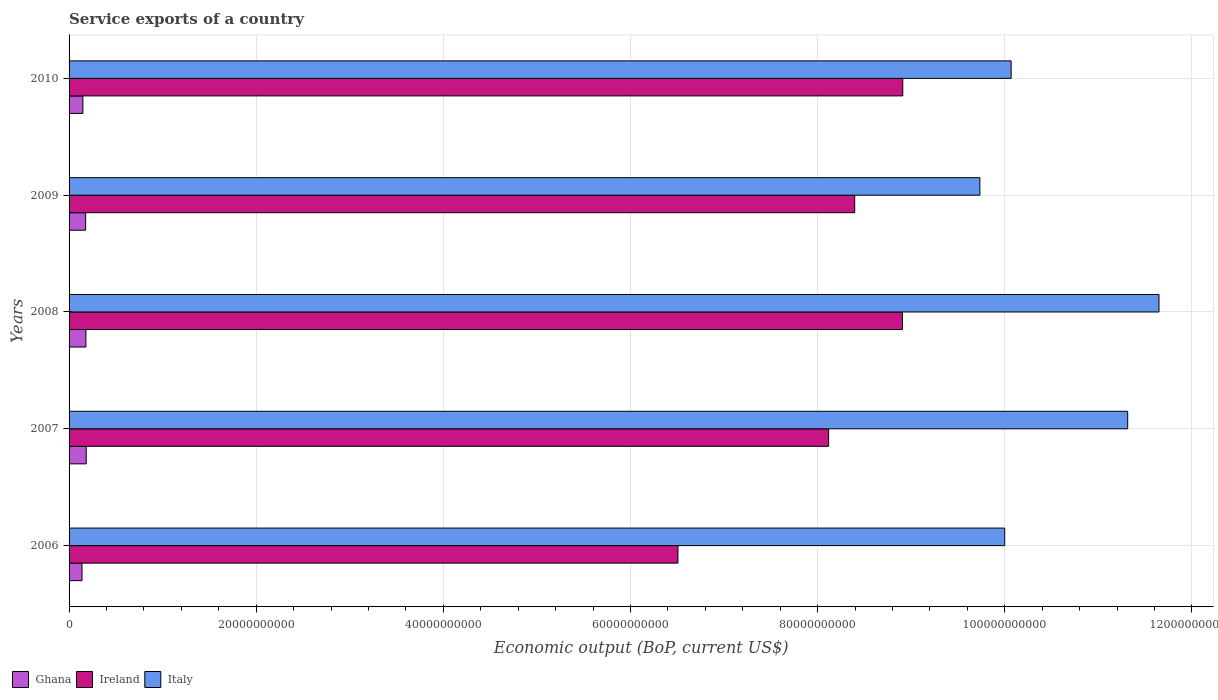How many different coloured bars are there?
Your answer should be compact. 3. How many groups of bars are there?
Your answer should be very brief. 5. Are the number of bars per tick equal to the number of legend labels?
Ensure brevity in your answer.  Yes. Are the number of bars on each tick of the Y-axis equal?
Make the answer very short. Yes. How many bars are there on the 4th tick from the top?
Your response must be concise. 3. How many bars are there on the 1st tick from the bottom?
Provide a short and direct response. 3. What is the label of the 5th group of bars from the top?
Keep it short and to the point. 2006. In how many cases, is the number of bars for a given year not equal to the number of legend labels?
Provide a short and direct response. 0. What is the service exports in Ireland in 2009?
Offer a very short reply. 8.40e+1. Across all years, what is the maximum service exports in Ghana?
Give a very brief answer. 1.83e+09. Across all years, what is the minimum service exports in Ireland?
Offer a terse response. 6.51e+1. In which year was the service exports in Ireland maximum?
Offer a very short reply. 2010. What is the total service exports in Ireland in the graph?
Provide a short and direct response. 4.08e+11. What is the difference between the service exports in Italy in 2006 and that in 2009?
Make the answer very short. 2.65e+09. What is the difference between the service exports in Italy in 2009 and the service exports in Ireland in 2007?
Offer a very short reply. 1.62e+1. What is the average service exports in Italy per year?
Offer a terse response. 1.06e+11. In the year 2010, what is the difference between the service exports in Ghana and service exports in Ireland?
Provide a succinct answer. -8.76e+1. In how many years, is the service exports in Italy greater than 68000000000 US$?
Provide a succinct answer. 5. What is the ratio of the service exports in Ireland in 2008 to that in 2009?
Give a very brief answer. 1.06. What is the difference between the highest and the second highest service exports in Italy?
Ensure brevity in your answer.  3.34e+09. What is the difference between the highest and the lowest service exports in Ghana?
Keep it short and to the point. 4.49e+08. In how many years, is the service exports in Italy greater than the average service exports in Italy taken over all years?
Provide a succinct answer. 2. Is the sum of the service exports in Ireland in 2006 and 2008 greater than the maximum service exports in Ghana across all years?
Make the answer very short. Yes. How many bars are there?
Offer a very short reply. 15. Are all the bars in the graph horizontal?
Provide a short and direct response. Yes. How many years are there in the graph?
Ensure brevity in your answer.  5. What is the difference between two consecutive major ticks on the X-axis?
Offer a terse response. 2.00e+1. Where does the legend appear in the graph?
Make the answer very short. Bottom left. How many legend labels are there?
Your answer should be very brief. 3. What is the title of the graph?
Provide a succinct answer. Service exports of a country. What is the label or title of the X-axis?
Your answer should be very brief. Economic output (BoP, current US$). What is the label or title of the Y-axis?
Provide a succinct answer. Years. What is the Economic output (BoP, current US$) of Ghana in 2006?
Your answer should be very brief. 1.38e+09. What is the Economic output (BoP, current US$) in Ireland in 2006?
Your response must be concise. 6.51e+1. What is the Economic output (BoP, current US$) of Italy in 2006?
Provide a short and direct response. 1.00e+11. What is the Economic output (BoP, current US$) in Ghana in 2007?
Offer a very short reply. 1.83e+09. What is the Economic output (BoP, current US$) of Ireland in 2007?
Provide a short and direct response. 8.12e+1. What is the Economic output (BoP, current US$) in Italy in 2007?
Offer a terse response. 1.13e+11. What is the Economic output (BoP, current US$) of Ghana in 2008?
Provide a short and direct response. 1.80e+09. What is the Economic output (BoP, current US$) in Ireland in 2008?
Provide a short and direct response. 8.91e+1. What is the Economic output (BoP, current US$) in Italy in 2008?
Provide a short and direct response. 1.16e+11. What is the Economic output (BoP, current US$) of Ghana in 2009?
Make the answer very short. 1.77e+09. What is the Economic output (BoP, current US$) in Ireland in 2009?
Offer a very short reply. 8.40e+1. What is the Economic output (BoP, current US$) of Italy in 2009?
Ensure brevity in your answer.  9.73e+1. What is the Economic output (BoP, current US$) in Ghana in 2010?
Keep it short and to the point. 1.48e+09. What is the Economic output (BoP, current US$) in Ireland in 2010?
Offer a very short reply. 8.91e+1. What is the Economic output (BoP, current US$) of Italy in 2010?
Your answer should be very brief. 1.01e+11. Across all years, what is the maximum Economic output (BoP, current US$) of Ghana?
Ensure brevity in your answer.  1.83e+09. Across all years, what is the maximum Economic output (BoP, current US$) in Ireland?
Your answer should be very brief. 8.91e+1. Across all years, what is the maximum Economic output (BoP, current US$) of Italy?
Give a very brief answer. 1.16e+11. Across all years, what is the minimum Economic output (BoP, current US$) in Ghana?
Your answer should be very brief. 1.38e+09. Across all years, what is the minimum Economic output (BoP, current US$) of Ireland?
Your answer should be compact. 6.51e+1. Across all years, what is the minimum Economic output (BoP, current US$) in Italy?
Your response must be concise. 9.73e+1. What is the total Economic output (BoP, current US$) in Ghana in the graph?
Offer a very short reply. 8.26e+09. What is the total Economic output (BoP, current US$) of Ireland in the graph?
Give a very brief answer. 4.08e+11. What is the total Economic output (BoP, current US$) in Italy in the graph?
Give a very brief answer. 5.28e+11. What is the difference between the Economic output (BoP, current US$) of Ghana in 2006 and that in 2007?
Your response must be concise. -4.49e+08. What is the difference between the Economic output (BoP, current US$) of Ireland in 2006 and that in 2007?
Your response must be concise. -1.61e+1. What is the difference between the Economic output (BoP, current US$) of Italy in 2006 and that in 2007?
Your answer should be very brief. -1.31e+1. What is the difference between the Economic output (BoP, current US$) in Ghana in 2006 and that in 2008?
Give a very brief answer. -4.18e+08. What is the difference between the Economic output (BoP, current US$) of Ireland in 2006 and that in 2008?
Give a very brief answer. -2.40e+1. What is the difference between the Economic output (BoP, current US$) of Italy in 2006 and that in 2008?
Ensure brevity in your answer.  -1.65e+1. What is the difference between the Economic output (BoP, current US$) of Ghana in 2006 and that in 2009?
Provide a succinct answer. -3.87e+08. What is the difference between the Economic output (BoP, current US$) in Ireland in 2006 and that in 2009?
Offer a very short reply. -1.89e+1. What is the difference between the Economic output (BoP, current US$) of Italy in 2006 and that in 2009?
Give a very brief answer. 2.65e+09. What is the difference between the Economic output (BoP, current US$) in Ghana in 2006 and that in 2010?
Your answer should be very brief. -9.45e+07. What is the difference between the Economic output (BoP, current US$) in Ireland in 2006 and that in 2010?
Give a very brief answer. -2.40e+1. What is the difference between the Economic output (BoP, current US$) of Italy in 2006 and that in 2010?
Offer a very short reply. -6.87e+08. What is the difference between the Economic output (BoP, current US$) of Ghana in 2007 and that in 2008?
Make the answer very short. 3.10e+07. What is the difference between the Economic output (BoP, current US$) of Ireland in 2007 and that in 2008?
Keep it short and to the point. -7.89e+09. What is the difference between the Economic output (BoP, current US$) of Italy in 2007 and that in 2008?
Your answer should be very brief. -3.34e+09. What is the difference between the Economic output (BoP, current US$) in Ghana in 2007 and that in 2009?
Provide a short and direct response. 6.22e+07. What is the difference between the Economic output (BoP, current US$) in Ireland in 2007 and that in 2009?
Offer a terse response. -2.79e+09. What is the difference between the Economic output (BoP, current US$) in Italy in 2007 and that in 2009?
Make the answer very short. 1.58e+1. What is the difference between the Economic output (BoP, current US$) of Ghana in 2007 and that in 2010?
Provide a short and direct response. 3.55e+08. What is the difference between the Economic output (BoP, current US$) in Ireland in 2007 and that in 2010?
Offer a terse response. -7.92e+09. What is the difference between the Economic output (BoP, current US$) of Italy in 2007 and that in 2010?
Ensure brevity in your answer.  1.25e+1. What is the difference between the Economic output (BoP, current US$) of Ghana in 2008 and that in 2009?
Your response must be concise. 3.12e+07. What is the difference between the Economic output (BoP, current US$) in Ireland in 2008 and that in 2009?
Offer a very short reply. 5.10e+09. What is the difference between the Economic output (BoP, current US$) of Italy in 2008 and that in 2009?
Make the answer very short. 1.91e+1. What is the difference between the Economic output (BoP, current US$) of Ghana in 2008 and that in 2010?
Make the answer very short. 3.24e+08. What is the difference between the Economic output (BoP, current US$) of Ireland in 2008 and that in 2010?
Make the answer very short. -3.44e+07. What is the difference between the Economic output (BoP, current US$) in Italy in 2008 and that in 2010?
Make the answer very short. 1.58e+1. What is the difference between the Economic output (BoP, current US$) of Ghana in 2009 and that in 2010?
Make the answer very short. 2.92e+08. What is the difference between the Economic output (BoP, current US$) in Ireland in 2009 and that in 2010?
Ensure brevity in your answer.  -5.14e+09. What is the difference between the Economic output (BoP, current US$) in Italy in 2009 and that in 2010?
Give a very brief answer. -3.34e+09. What is the difference between the Economic output (BoP, current US$) in Ghana in 2006 and the Economic output (BoP, current US$) in Ireland in 2007?
Your answer should be compact. -7.98e+1. What is the difference between the Economic output (BoP, current US$) of Ghana in 2006 and the Economic output (BoP, current US$) of Italy in 2007?
Make the answer very short. -1.12e+11. What is the difference between the Economic output (BoP, current US$) in Ireland in 2006 and the Economic output (BoP, current US$) in Italy in 2007?
Keep it short and to the point. -4.81e+1. What is the difference between the Economic output (BoP, current US$) in Ghana in 2006 and the Economic output (BoP, current US$) in Ireland in 2008?
Provide a short and direct response. -8.77e+1. What is the difference between the Economic output (BoP, current US$) in Ghana in 2006 and the Economic output (BoP, current US$) in Italy in 2008?
Offer a very short reply. -1.15e+11. What is the difference between the Economic output (BoP, current US$) in Ireland in 2006 and the Economic output (BoP, current US$) in Italy in 2008?
Keep it short and to the point. -5.14e+1. What is the difference between the Economic output (BoP, current US$) in Ghana in 2006 and the Economic output (BoP, current US$) in Ireland in 2009?
Give a very brief answer. -8.26e+1. What is the difference between the Economic output (BoP, current US$) of Ghana in 2006 and the Economic output (BoP, current US$) of Italy in 2009?
Ensure brevity in your answer.  -9.60e+1. What is the difference between the Economic output (BoP, current US$) in Ireland in 2006 and the Economic output (BoP, current US$) in Italy in 2009?
Provide a succinct answer. -3.23e+1. What is the difference between the Economic output (BoP, current US$) in Ghana in 2006 and the Economic output (BoP, current US$) in Ireland in 2010?
Give a very brief answer. -8.77e+1. What is the difference between the Economic output (BoP, current US$) in Ghana in 2006 and the Economic output (BoP, current US$) in Italy in 2010?
Your answer should be very brief. -9.93e+1. What is the difference between the Economic output (BoP, current US$) in Ireland in 2006 and the Economic output (BoP, current US$) in Italy in 2010?
Provide a short and direct response. -3.56e+1. What is the difference between the Economic output (BoP, current US$) of Ghana in 2007 and the Economic output (BoP, current US$) of Ireland in 2008?
Offer a terse response. -8.72e+1. What is the difference between the Economic output (BoP, current US$) in Ghana in 2007 and the Economic output (BoP, current US$) in Italy in 2008?
Your response must be concise. -1.15e+11. What is the difference between the Economic output (BoP, current US$) of Ireland in 2007 and the Economic output (BoP, current US$) of Italy in 2008?
Provide a short and direct response. -3.53e+1. What is the difference between the Economic output (BoP, current US$) of Ghana in 2007 and the Economic output (BoP, current US$) of Ireland in 2009?
Your answer should be compact. -8.21e+1. What is the difference between the Economic output (BoP, current US$) in Ghana in 2007 and the Economic output (BoP, current US$) in Italy in 2009?
Your answer should be very brief. -9.55e+1. What is the difference between the Economic output (BoP, current US$) of Ireland in 2007 and the Economic output (BoP, current US$) of Italy in 2009?
Your answer should be very brief. -1.62e+1. What is the difference between the Economic output (BoP, current US$) in Ghana in 2007 and the Economic output (BoP, current US$) in Ireland in 2010?
Offer a very short reply. -8.73e+1. What is the difference between the Economic output (BoP, current US$) in Ghana in 2007 and the Economic output (BoP, current US$) in Italy in 2010?
Make the answer very short. -9.88e+1. What is the difference between the Economic output (BoP, current US$) in Ireland in 2007 and the Economic output (BoP, current US$) in Italy in 2010?
Offer a terse response. -1.95e+1. What is the difference between the Economic output (BoP, current US$) of Ghana in 2008 and the Economic output (BoP, current US$) of Ireland in 2009?
Offer a terse response. -8.22e+1. What is the difference between the Economic output (BoP, current US$) in Ghana in 2008 and the Economic output (BoP, current US$) in Italy in 2009?
Offer a terse response. -9.55e+1. What is the difference between the Economic output (BoP, current US$) of Ireland in 2008 and the Economic output (BoP, current US$) of Italy in 2009?
Make the answer very short. -8.27e+09. What is the difference between the Economic output (BoP, current US$) of Ghana in 2008 and the Economic output (BoP, current US$) of Ireland in 2010?
Your answer should be very brief. -8.73e+1. What is the difference between the Economic output (BoP, current US$) of Ghana in 2008 and the Economic output (BoP, current US$) of Italy in 2010?
Offer a terse response. -9.89e+1. What is the difference between the Economic output (BoP, current US$) of Ireland in 2008 and the Economic output (BoP, current US$) of Italy in 2010?
Provide a succinct answer. -1.16e+1. What is the difference between the Economic output (BoP, current US$) of Ghana in 2009 and the Economic output (BoP, current US$) of Ireland in 2010?
Make the answer very short. -8.73e+1. What is the difference between the Economic output (BoP, current US$) of Ghana in 2009 and the Economic output (BoP, current US$) of Italy in 2010?
Keep it short and to the point. -9.89e+1. What is the difference between the Economic output (BoP, current US$) in Ireland in 2009 and the Economic output (BoP, current US$) in Italy in 2010?
Offer a terse response. -1.67e+1. What is the average Economic output (BoP, current US$) in Ghana per year?
Provide a short and direct response. 1.65e+09. What is the average Economic output (BoP, current US$) in Ireland per year?
Your answer should be compact. 8.17e+1. What is the average Economic output (BoP, current US$) of Italy per year?
Offer a very short reply. 1.06e+11. In the year 2006, what is the difference between the Economic output (BoP, current US$) of Ghana and Economic output (BoP, current US$) of Ireland?
Your response must be concise. -6.37e+1. In the year 2006, what is the difference between the Economic output (BoP, current US$) in Ghana and Economic output (BoP, current US$) in Italy?
Ensure brevity in your answer.  -9.86e+1. In the year 2006, what is the difference between the Economic output (BoP, current US$) in Ireland and Economic output (BoP, current US$) in Italy?
Ensure brevity in your answer.  -3.49e+1. In the year 2007, what is the difference between the Economic output (BoP, current US$) in Ghana and Economic output (BoP, current US$) in Ireland?
Keep it short and to the point. -7.93e+1. In the year 2007, what is the difference between the Economic output (BoP, current US$) in Ghana and Economic output (BoP, current US$) in Italy?
Your answer should be very brief. -1.11e+11. In the year 2007, what is the difference between the Economic output (BoP, current US$) in Ireland and Economic output (BoP, current US$) in Italy?
Your response must be concise. -3.20e+1. In the year 2008, what is the difference between the Economic output (BoP, current US$) in Ghana and Economic output (BoP, current US$) in Ireland?
Make the answer very short. -8.73e+1. In the year 2008, what is the difference between the Economic output (BoP, current US$) of Ghana and Economic output (BoP, current US$) of Italy?
Offer a terse response. -1.15e+11. In the year 2008, what is the difference between the Economic output (BoP, current US$) in Ireland and Economic output (BoP, current US$) in Italy?
Ensure brevity in your answer.  -2.74e+1. In the year 2009, what is the difference between the Economic output (BoP, current US$) of Ghana and Economic output (BoP, current US$) of Ireland?
Your answer should be compact. -8.22e+1. In the year 2009, what is the difference between the Economic output (BoP, current US$) of Ghana and Economic output (BoP, current US$) of Italy?
Provide a short and direct response. -9.56e+1. In the year 2009, what is the difference between the Economic output (BoP, current US$) of Ireland and Economic output (BoP, current US$) of Italy?
Provide a succinct answer. -1.34e+1. In the year 2010, what is the difference between the Economic output (BoP, current US$) in Ghana and Economic output (BoP, current US$) in Ireland?
Provide a succinct answer. -8.76e+1. In the year 2010, what is the difference between the Economic output (BoP, current US$) of Ghana and Economic output (BoP, current US$) of Italy?
Make the answer very short. -9.92e+1. In the year 2010, what is the difference between the Economic output (BoP, current US$) in Ireland and Economic output (BoP, current US$) in Italy?
Provide a succinct answer. -1.16e+1. What is the ratio of the Economic output (BoP, current US$) of Ghana in 2006 to that in 2007?
Keep it short and to the point. 0.75. What is the ratio of the Economic output (BoP, current US$) in Ireland in 2006 to that in 2007?
Give a very brief answer. 0.8. What is the ratio of the Economic output (BoP, current US$) of Italy in 2006 to that in 2007?
Your response must be concise. 0.88. What is the ratio of the Economic output (BoP, current US$) of Ghana in 2006 to that in 2008?
Your answer should be compact. 0.77. What is the ratio of the Economic output (BoP, current US$) of Ireland in 2006 to that in 2008?
Make the answer very short. 0.73. What is the ratio of the Economic output (BoP, current US$) of Italy in 2006 to that in 2008?
Offer a terse response. 0.86. What is the ratio of the Economic output (BoP, current US$) in Ghana in 2006 to that in 2009?
Make the answer very short. 0.78. What is the ratio of the Economic output (BoP, current US$) of Ireland in 2006 to that in 2009?
Provide a short and direct response. 0.78. What is the ratio of the Economic output (BoP, current US$) in Italy in 2006 to that in 2009?
Give a very brief answer. 1.03. What is the ratio of the Economic output (BoP, current US$) in Ghana in 2006 to that in 2010?
Offer a very short reply. 0.94. What is the ratio of the Economic output (BoP, current US$) in Ireland in 2006 to that in 2010?
Give a very brief answer. 0.73. What is the ratio of the Economic output (BoP, current US$) of Italy in 2006 to that in 2010?
Provide a short and direct response. 0.99. What is the ratio of the Economic output (BoP, current US$) in Ghana in 2007 to that in 2008?
Provide a succinct answer. 1.02. What is the ratio of the Economic output (BoP, current US$) in Ireland in 2007 to that in 2008?
Your answer should be very brief. 0.91. What is the ratio of the Economic output (BoP, current US$) of Italy in 2007 to that in 2008?
Provide a succinct answer. 0.97. What is the ratio of the Economic output (BoP, current US$) in Ghana in 2007 to that in 2009?
Offer a terse response. 1.04. What is the ratio of the Economic output (BoP, current US$) of Ireland in 2007 to that in 2009?
Make the answer very short. 0.97. What is the ratio of the Economic output (BoP, current US$) of Italy in 2007 to that in 2009?
Your answer should be very brief. 1.16. What is the ratio of the Economic output (BoP, current US$) in Ghana in 2007 to that in 2010?
Keep it short and to the point. 1.24. What is the ratio of the Economic output (BoP, current US$) of Ireland in 2007 to that in 2010?
Offer a very short reply. 0.91. What is the ratio of the Economic output (BoP, current US$) of Italy in 2007 to that in 2010?
Your answer should be compact. 1.12. What is the ratio of the Economic output (BoP, current US$) in Ghana in 2008 to that in 2009?
Ensure brevity in your answer.  1.02. What is the ratio of the Economic output (BoP, current US$) in Ireland in 2008 to that in 2009?
Provide a succinct answer. 1.06. What is the ratio of the Economic output (BoP, current US$) in Italy in 2008 to that in 2009?
Provide a succinct answer. 1.2. What is the ratio of the Economic output (BoP, current US$) in Ghana in 2008 to that in 2010?
Your answer should be very brief. 1.22. What is the ratio of the Economic output (BoP, current US$) in Ireland in 2008 to that in 2010?
Keep it short and to the point. 1. What is the ratio of the Economic output (BoP, current US$) in Italy in 2008 to that in 2010?
Your answer should be very brief. 1.16. What is the ratio of the Economic output (BoP, current US$) in Ghana in 2009 to that in 2010?
Your answer should be compact. 1.2. What is the ratio of the Economic output (BoP, current US$) in Ireland in 2009 to that in 2010?
Your response must be concise. 0.94. What is the ratio of the Economic output (BoP, current US$) of Italy in 2009 to that in 2010?
Your response must be concise. 0.97. What is the difference between the highest and the second highest Economic output (BoP, current US$) in Ghana?
Offer a terse response. 3.10e+07. What is the difference between the highest and the second highest Economic output (BoP, current US$) in Ireland?
Keep it short and to the point. 3.44e+07. What is the difference between the highest and the second highest Economic output (BoP, current US$) in Italy?
Offer a terse response. 3.34e+09. What is the difference between the highest and the lowest Economic output (BoP, current US$) in Ghana?
Give a very brief answer. 4.49e+08. What is the difference between the highest and the lowest Economic output (BoP, current US$) in Ireland?
Offer a very short reply. 2.40e+1. What is the difference between the highest and the lowest Economic output (BoP, current US$) of Italy?
Provide a succinct answer. 1.91e+1. 